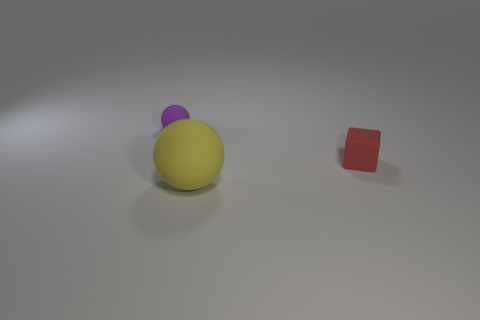There is a ball behind the yellow thing in front of the tiny thing to the left of the large matte sphere; what is it made of?
Offer a very short reply. Rubber. There is a object behind the small cube; what number of things are in front of it?
Make the answer very short. 2. What is the color of the other tiny rubber object that is the same shape as the yellow object?
Offer a terse response. Purple. Are the yellow thing and the tiny cube made of the same material?
Your answer should be compact. Yes. How many cylinders are either large yellow matte things or tiny blue metallic things?
Provide a succinct answer. 0. What is the size of the matte thing in front of the tiny thing right of the sphere in front of the rubber cube?
Offer a very short reply. Large. There is another matte object that is the same shape as the yellow object; what size is it?
Keep it short and to the point. Small. What number of small rubber objects are to the left of the big ball?
Your answer should be very brief. 1. There is a tiny object that is right of the small purple object; does it have the same color as the large rubber thing?
Your answer should be compact. No. What number of green things are either blocks or spheres?
Provide a succinct answer. 0. 